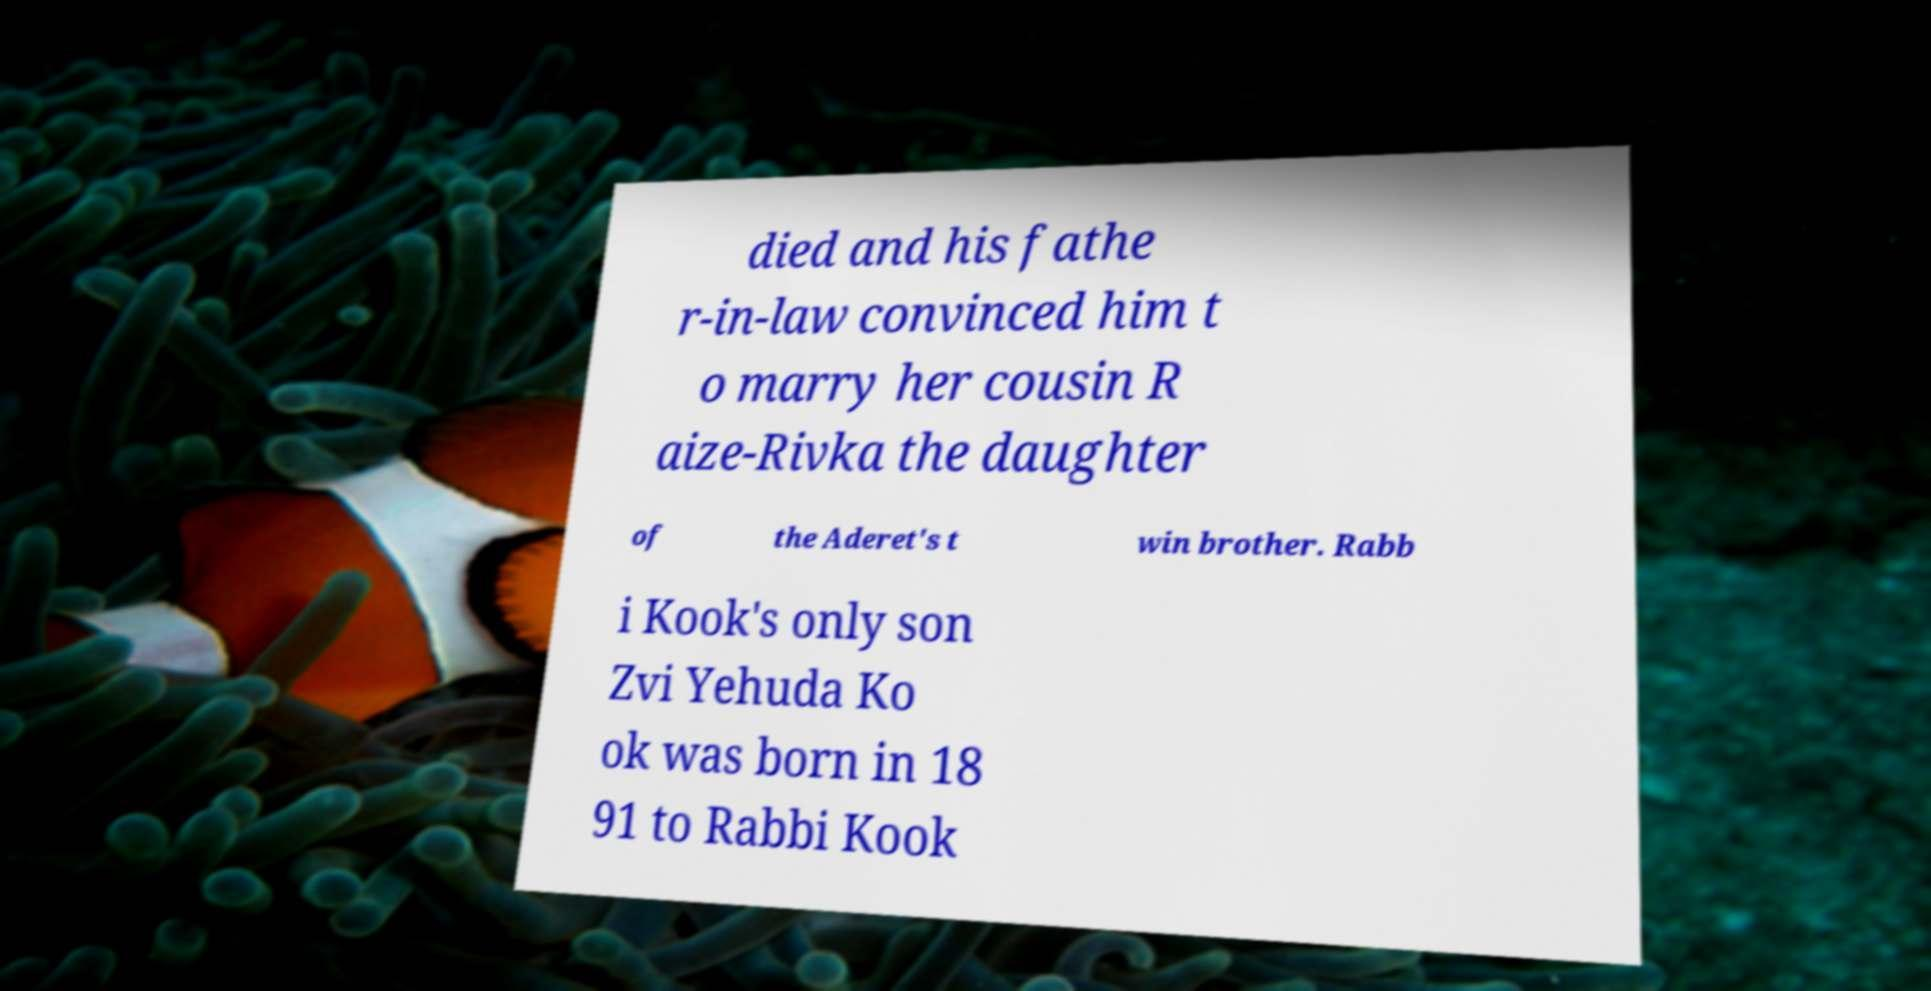Please read and relay the text visible in this image. What does it say? died and his fathe r-in-law convinced him t o marry her cousin R aize-Rivka the daughter of the Aderet's t win brother. Rabb i Kook's only son Zvi Yehuda Ko ok was born in 18 91 to Rabbi Kook 